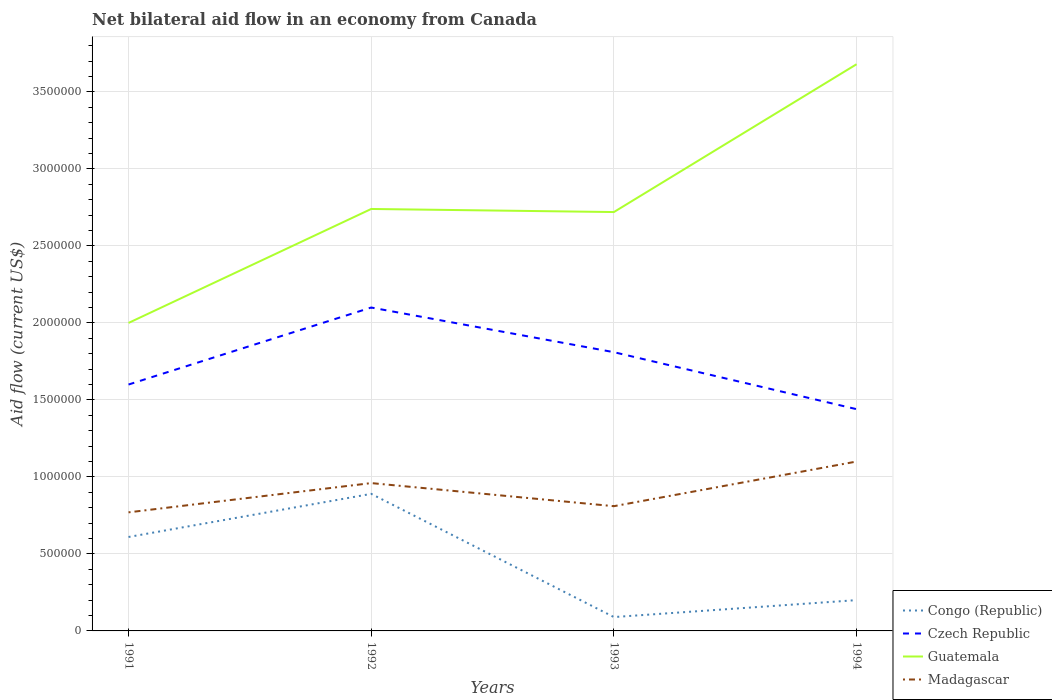Across all years, what is the maximum net bilateral aid flow in Madagascar?
Keep it short and to the point. 7.70e+05. What is the total net bilateral aid flow in Madagascar in the graph?
Offer a very short reply. -4.00e+04. What is the difference between the highest and the second highest net bilateral aid flow in Guatemala?
Make the answer very short. 1.68e+06. What is the difference between the highest and the lowest net bilateral aid flow in Congo (Republic)?
Offer a terse response. 2. Is the net bilateral aid flow in Guatemala strictly greater than the net bilateral aid flow in Madagascar over the years?
Keep it short and to the point. No. How many years are there in the graph?
Provide a succinct answer. 4. Does the graph contain grids?
Your answer should be very brief. Yes. Where does the legend appear in the graph?
Offer a terse response. Bottom right. How are the legend labels stacked?
Give a very brief answer. Vertical. What is the title of the graph?
Keep it short and to the point. Net bilateral aid flow in an economy from Canada. Does "Dominica" appear as one of the legend labels in the graph?
Provide a succinct answer. No. What is the label or title of the X-axis?
Offer a terse response. Years. What is the label or title of the Y-axis?
Give a very brief answer. Aid flow (current US$). What is the Aid flow (current US$) in Czech Republic in 1991?
Keep it short and to the point. 1.60e+06. What is the Aid flow (current US$) of Guatemala in 1991?
Provide a succinct answer. 2.00e+06. What is the Aid flow (current US$) in Madagascar in 1991?
Offer a very short reply. 7.70e+05. What is the Aid flow (current US$) in Congo (Republic) in 1992?
Ensure brevity in your answer.  8.90e+05. What is the Aid flow (current US$) of Czech Republic in 1992?
Give a very brief answer. 2.10e+06. What is the Aid flow (current US$) of Guatemala in 1992?
Keep it short and to the point. 2.74e+06. What is the Aid flow (current US$) in Madagascar in 1992?
Your answer should be compact. 9.60e+05. What is the Aid flow (current US$) of Czech Republic in 1993?
Your answer should be compact. 1.81e+06. What is the Aid flow (current US$) in Guatemala in 1993?
Your answer should be very brief. 2.72e+06. What is the Aid flow (current US$) in Madagascar in 1993?
Ensure brevity in your answer.  8.10e+05. What is the Aid flow (current US$) of Czech Republic in 1994?
Give a very brief answer. 1.44e+06. What is the Aid flow (current US$) of Guatemala in 1994?
Offer a very short reply. 3.68e+06. What is the Aid flow (current US$) in Madagascar in 1994?
Your answer should be compact. 1.10e+06. Across all years, what is the maximum Aid flow (current US$) in Congo (Republic)?
Give a very brief answer. 8.90e+05. Across all years, what is the maximum Aid flow (current US$) in Czech Republic?
Ensure brevity in your answer.  2.10e+06. Across all years, what is the maximum Aid flow (current US$) in Guatemala?
Your answer should be very brief. 3.68e+06. Across all years, what is the maximum Aid flow (current US$) of Madagascar?
Your answer should be very brief. 1.10e+06. Across all years, what is the minimum Aid flow (current US$) in Czech Republic?
Keep it short and to the point. 1.44e+06. Across all years, what is the minimum Aid flow (current US$) in Guatemala?
Make the answer very short. 2.00e+06. Across all years, what is the minimum Aid flow (current US$) of Madagascar?
Your answer should be very brief. 7.70e+05. What is the total Aid flow (current US$) in Congo (Republic) in the graph?
Give a very brief answer. 1.79e+06. What is the total Aid flow (current US$) of Czech Republic in the graph?
Your answer should be very brief. 6.95e+06. What is the total Aid flow (current US$) of Guatemala in the graph?
Offer a very short reply. 1.11e+07. What is the total Aid flow (current US$) of Madagascar in the graph?
Keep it short and to the point. 3.64e+06. What is the difference between the Aid flow (current US$) in Congo (Republic) in 1991 and that in 1992?
Make the answer very short. -2.80e+05. What is the difference between the Aid flow (current US$) in Czech Republic in 1991 and that in 1992?
Offer a terse response. -5.00e+05. What is the difference between the Aid flow (current US$) of Guatemala in 1991 and that in 1992?
Provide a short and direct response. -7.40e+05. What is the difference between the Aid flow (current US$) in Congo (Republic) in 1991 and that in 1993?
Offer a terse response. 5.20e+05. What is the difference between the Aid flow (current US$) in Guatemala in 1991 and that in 1993?
Ensure brevity in your answer.  -7.20e+05. What is the difference between the Aid flow (current US$) of Guatemala in 1991 and that in 1994?
Your answer should be compact. -1.68e+06. What is the difference between the Aid flow (current US$) in Madagascar in 1991 and that in 1994?
Offer a very short reply. -3.30e+05. What is the difference between the Aid flow (current US$) of Congo (Republic) in 1992 and that in 1993?
Give a very brief answer. 8.00e+05. What is the difference between the Aid flow (current US$) of Czech Republic in 1992 and that in 1993?
Your response must be concise. 2.90e+05. What is the difference between the Aid flow (current US$) of Guatemala in 1992 and that in 1993?
Provide a succinct answer. 2.00e+04. What is the difference between the Aid flow (current US$) of Congo (Republic) in 1992 and that in 1994?
Offer a terse response. 6.90e+05. What is the difference between the Aid flow (current US$) of Guatemala in 1992 and that in 1994?
Make the answer very short. -9.40e+05. What is the difference between the Aid flow (current US$) in Madagascar in 1992 and that in 1994?
Provide a succinct answer. -1.40e+05. What is the difference between the Aid flow (current US$) in Guatemala in 1993 and that in 1994?
Ensure brevity in your answer.  -9.60e+05. What is the difference between the Aid flow (current US$) in Congo (Republic) in 1991 and the Aid flow (current US$) in Czech Republic in 1992?
Offer a very short reply. -1.49e+06. What is the difference between the Aid flow (current US$) of Congo (Republic) in 1991 and the Aid flow (current US$) of Guatemala in 1992?
Your answer should be very brief. -2.13e+06. What is the difference between the Aid flow (current US$) of Congo (Republic) in 1991 and the Aid flow (current US$) of Madagascar in 1992?
Give a very brief answer. -3.50e+05. What is the difference between the Aid flow (current US$) in Czech Republic in 1991 and the Aid flow (current US$) in Guatemala in 1992?
Give a very brief answer. -1.14e+06. What is the difference between the Aid flow (current US$) of Czech Republic in 1991 and the Aid flow (current US$) of Madagascar in 1992?
Give a very brief answer. 6.40e+05. What is the difference between the Aid flow (current US$) in Guatemala in 1991 and the Aid flow (current US$) in Madagascar in 1992?
Your answer should be very brief. 1.04e+06. What is the difference between the Aid flow (current US$) in Congo (Republic) in 1991 and the Aid flow (current US$) in Czech Republic in 1993?
Offer a very short reply. -1.20e+06. What is the difference between the Aid flow (current US$) of Congo (Republic) in 1991 and the Aid flow (current US$) of Guatemala in 1993?
Offer a very short reply. -2.11e+06. What is the difference between the Aid flow (current US$) of Congo (Republic) in 1991 and the Aid flow (current US$) of Madagascar in 1993?
Offer a very short reply. -2.00e+05. What is the difference between the Aid flow (current US$) in Czech Republic in 1991 and the Aid flow (current US$) in Guatemala in 1993?
Provide a succinct answer. -1.12e+06. What is the difference between the Aid flow (current US$) in Czech Republic in 1991 and the Aid flow (current US$) in Madagascar in 1993?
Keep it short and to the point. 7.90e+05. What is the difference between the Aid flow (current US$) in Guatemala in 1991 and the Aid flow (current US$) in Madagascar in 1993?
Offer a terse response. 1.19e+06. What is the difference between the Aid flow (current US$) in Congo (Republic) in 1991 and the Aid flow (current US$) in Czech Republic in 1994?
Keep it short and to the point. -8.30e+05. What is the difference between the Aid flow (current US$) in Congo (Republic) in 1991 and the Aid flow (current US$) in Guatemala in 1994?
Offer a very short reply. -3.07e+06. What is the difference between the Aid flow (current US$) in Congo (Republic) in 1991 and the Aid flow (current US$) in Madagascar in 1994?
Ensure brevity in your answer.  -4.90e+05. What is the difference between the Aid flow (current US$) in Czech Republic in 1991 and the Aid flow (current US$) in Guatemala in 1994?
Your response must be concise. -2.08e+06. What is the difference between the Aid flow (current US$) of Guatemala in 1991 and the Aid flow (current US$) of Madagascar in 1994?
Offer a very short reply. 9.00e+05. What is the difference between the Aid flow (current US$) in Congo (Republic) in 1992 and the Aid flow (current US$) in Czech Republic in 1993?
Provide a short and direct response. -9.20e+05. What is the difference between the Aid flow (current US$) of Congo (Republic) in 1992 and the Aid flow (current US$) of Guatemala in 1993?
Offer a very short reply. -1.83e+06. What is the difference between the Aid flow (current US$) in Czech Republic in 1992 and the Aid flow (current US$) in Guatemala in 1993?
Give a very brief answer. -6.20e+05. What is the difference between the Aid flow (current US$) in Czech Republic in 1992 and the Aid flow (current US$) in Madagascar in 1993?
Give a very brief answer. 1.29e+06. What is the difference between the Aid flow (current US$) of Guatemala in 1992 and the Aid flow (current US$) of Madagascar in 1993?
Ensure brevity in your answer.  1.93e+06. What is the difference between the Aid flow (current US$) in Congo (Republic) in 1992 and the Aid flow (current US$) in Czech Republic in 1994?
Provide a short and direct response. -5.50e+05. What is the difference between the Aid flow (current US$) in Congo (Republic) in 1992 and the Aid flow (current US$) in Guatemala in 1994?
Keep it short and to the point. -2.79e+06. What is the difference between the Aid flow (current US$) in Congo (Republic) in 1992 and the Aid flow (current US$) in Madagascar in 1994?
Provide a short and direct response. -2.10e+05. What is the difference between the Aid flow (current US$) in Czech Republic in 1992 and the Aid flow (current US$) in Guatemala in 1994?
Make the answer very short. -1.58e+06. What is the difference between the Aid flow (current US$) in Guatemala in 1992 and the Aid flow (current US$) in Madagascar in 1994?
Your response must be concise. 1.64e+06. What is the difference between the Aid flow (current US$) of Congo (Republic) in 1993 and the Aid flow (current US$) of Czech Republic in 1994?
Your answer should be compact. -1.35e+06. What is the difference between the Aid flow (current US$) in Congo (Republic) in 1993 and the Aid flow (current US$) in Guatemala in 1994?
Keep it short and to the point. -3.59e+06. What is the difference between the Aid flow (current US$) of Congo (Republic) in 1993 and the Aid flow (current US$) of Madagascar in 1994?
Your answer should be very brief. -1.01e+06. What is the difference between the Aid flow (current US$) of Czech Republic in 1993 and the Aid flow (current US$) of Guatemala in 1994?
Offer a very short reply. -1.87e+06. What is the difference between the Aid flow (current US$) in Czech Republic in 1993 and the Aid flow (current US$) in Madagascar in 1994?
Offer a very short reply. 7.10e+05. What is the difference between the Aid flow (current US$) in Guatemala in 1993 and the Aid flow (current US$) in Madagascar in 1994?
Your answer should be very brief. 1.62e+06. What is the average Aid flow (current US$) of Congo (Republic) per year?
Offer a terse response. 4.48e+05. What is the average Aid flow (current US$) in Czech Republic per year?
Your response must be concise. 1.74e+06. What is the average Aid flow (current US$) of Guatemala per year?
Your answer should be compact. 2.78e+06. What is the average Aid flow (current US$) of Madagascar per year?
Keep it short and to the point. 9.10e+05. In the year 1991, what is the difference between the Aid flow (current US$) of Congo (Republic) and Aid flow (current US$) of Czech Republic?
Your response must be concise. -9.90e+05. In the year 1991, what is the difference between the Aid flow (current US$) of Congo (Republic) and Aid flow (current US$) of Guatemala?
Provide a succinct answer. -1.39e+06. In the year 1991, what is the difference between the Aid flow (current US$) in Congo (Republic) and Aid flow (current US$) in Madagascar?
Your response must be concise. -1.60e+05. In the year 1991, what is the difference between the Aid flow (current US$) of Czech Republic and Aid flow (current US$) of Guatemala?
Make the answer very short. -4.00e+05. In the year 1991, what is the difference between the Aid flow (current US$) in Czech Republic and Aid flow (current US$) in Madagascar?
Your response must be concise. 8.30e+05. In the year 1991, what is the difference between the Aid flow (current US$) in Guatemala and Aid flow (current US$) in Madagascar?
Offer a terse response. 1.23e+06. In the year 1992, what is the difference between the Aid flow (current US$) in Congo (Republic) and Aid flow (current US$) in Czech Republic?
Provide a short and direct response. -1.21e+06. In the year 1992, what is the difference between the Aid flow (current US$) in Congo (Republic) and Aid flow (current US$) in Guatemala?
Keep it short and to the point. -1.85e+06. In the year 1992, what is the difference between the Aid flow (current US$) in Czech Republic and Aid flow (current US$) in Guatemala?
Ensure brevity in your answer.  -6.40e+05. In the year 1992, what is the difference between the Aid flow (current US$) in Czech Republic and Aid flow (current US$) in Madagascar?
Offer a very short reply. 1.14e+06. In the year 1992, what is the difference between the Aid flow (current US$) in Guatemala and Aid flow (current US$) in Madagascar?
Give a very brief answer. 1.78e+06. In the year 1993, what is the difference between the Aid flow (current US$) of Congo (Republic) and Aid flow (current US$) of Czech Republic?
Offer a terse response. -1.72e+06. In the year 1993, what is the difference between the Aid flow (current US$) of Congo (Republic) and Aid flow (current US$) of Guatemala?
Your answer should be compact. -2.63e+06. In the year 1993, what is the difference between the Aid flow (current US$) in Congo (Republic) and Aid flow (current US$) in Madagascar?
Ensure brevity in your answer.  -7.20e+05. In the year 1993, what is the difference between the Aid flow (current US$) of Czech Republic and Aid flow (current US$) of Guatemala?
Provide a short and direct response. -9.10e+05. In the year 1993, what is the difference between the Aid flow (current US$) in Guatemala and Aid flow (current US$) in Madagascar?
Make the answer very short. 1.91e+06. In the year 1994, what is the difference between the Aid flow (current US$) of Congo (Republic) and Aid flow (current US$) of Czech Republic?
Keep it short and to the point. -1.24e+06. In the year 1994, what is the difference between the Aid flow (current US$) in Congo (Republic) and Aid flow (current US$) in Guatemala?
Keep it short and to the point. -3.48e+06. In the year 1994, what is the difference between the Aid flow (current US$) of Congo (Republic) and Aid flow (current US$) of Madagascar?
Ensure brevity in your answer.  -9.00e+05. In the year 1994, what is the difference between the Aid flow (current US$) of Czech Republic and Aid flow (current US$) of Guatemala?
Make the answer very short. -2.24e+06. In the year 1994, what is the difference between the Aid flow (current US$) of Czech Republic and Aid flow (current US$) of Madagascar?
Provide a short and direct response. 3.40e+05. In the year 1994, what is the difference between the Aid flow (current US$) of Guatemala and Aid flow (current US$) of Madagascar?
Provide a succinct answer. 2.58e+06. What is the ratio of the Aid flow (current US$) of Congo (Republic) in 1991 to that in 1992?
Offer a terse response. 0.69. What is the ratio of the Aid flow (current US$) of Czech Republic in 1991 to that in 1992?
Provide a short and direct response. 0.76. What is the ratio of the Aid flow (current US$) of Guatemala in 1991 to that in 1992?
Give a very brief answer. 0.73. What is the ratio of the Aid flow (current US$) of Madagascar in 1991 to that in 1992?
Give a very brief answer. 0.8. What is the ratio of the Aid flow (current US$) in Congo (Republic) in 1991 to that in 1993?
Provide a succinct answer. 6.78. What is the ratio of the Aid flow (current US$) of Czech Republic in 1991 to that in 1993?
Give a very brief answer. 0.88. What is the ratio of the Aid flow (current US$) in Guatemala in 1991 to that in 1993?
Offer a terse response. 0.74. What is the ratio of the Aid flow (current US$) in Madagascar in 1991 to that in 1993?
Your answer should be compact. 0.95. What is the ratio of the Aid flow (current US$) in Congo (Republic) in 1991 to that in 1994?
Your response must be concise. 3.05. What is the ratio of the Aid flow (current US$) in Guatemala in 1991 to that in 1994?
Ensure brevity in your answer.  0.54. What is the ratio of the Aid flow (current US$) in Madagascar in 1991 to that in 1994?
Provide a short and direct response. 0.7. What is the ratio of the Aid flow (current US$) of Congo (Republic) in 1992 to that in 1993?
Your response must be concise. 9.89. What is the ratio of the Aid flow (current US$) in Czech Republic in 1992 to that in 1993?
Offer a very short reply. 1.16. What is the ratio of the Aid flow (current US$) of Guatemala in 1992 to that in 1993?
Provide a short and direct response. 1.01. What is the ratio of the Aid flow (current US$) of Madagascar in 1992 to that in 1993?
Your answer should be very brief. 1.19. What is the ratio of the Aid flow (current US$) of Congo (Republic) in 1992 to that in 1994?
Your answer should be compact. 4.45. What is the ratio of the Aid flow (current US$) in Czech Republic in 1992 to that in 1994?
Give a very brief answer. 1.46. What is the ratio of the Aid flow (current US$) of Guatemala in 1992 to that in 1994?
Provide a succinct answer. 0.74. What is the ratio of the Aid flow (current US$) of Madagascar in 1992 to that in 1994?
Your answer should be compact. 0.87. What is the ratio of the Aid flow (current US$) in Congo (Republic) in 1993 to that in 1994?
Give a very brief answer. 0.45. What is the ratio of the Aid flow (current US$) in Czech Republic in 1993 to that in 1994?
Make the answer very short. 1.26. What is the ratio of the Aid flow (current US$) in Guatemala in 1993 to that in 1994?
Offer a terse response. 0.74. What is the ratio of the Aid flow (current US$) of Madagascar in 1993 to that in 1994?
Make the answer very short. 0.74. What is the difference between the highest and the second highest Aid flow (current US$) in Czech Republic?
Provide a short and direct response. 2.90e+05. What is the difference between the highest and the second highest Aid flow (current US$) of Guatemala?
Ensure brevity in your answer.  9.40e+05. What is the difference between the highest and the second highest Aid flow (current US$) of Madagascar?
Make the answer very short. 1.40e+05. What is the difference between the highest and the lowest Aid flow (current US$) in Guatemala?
Give a very brief answer. 1.68e+06. 